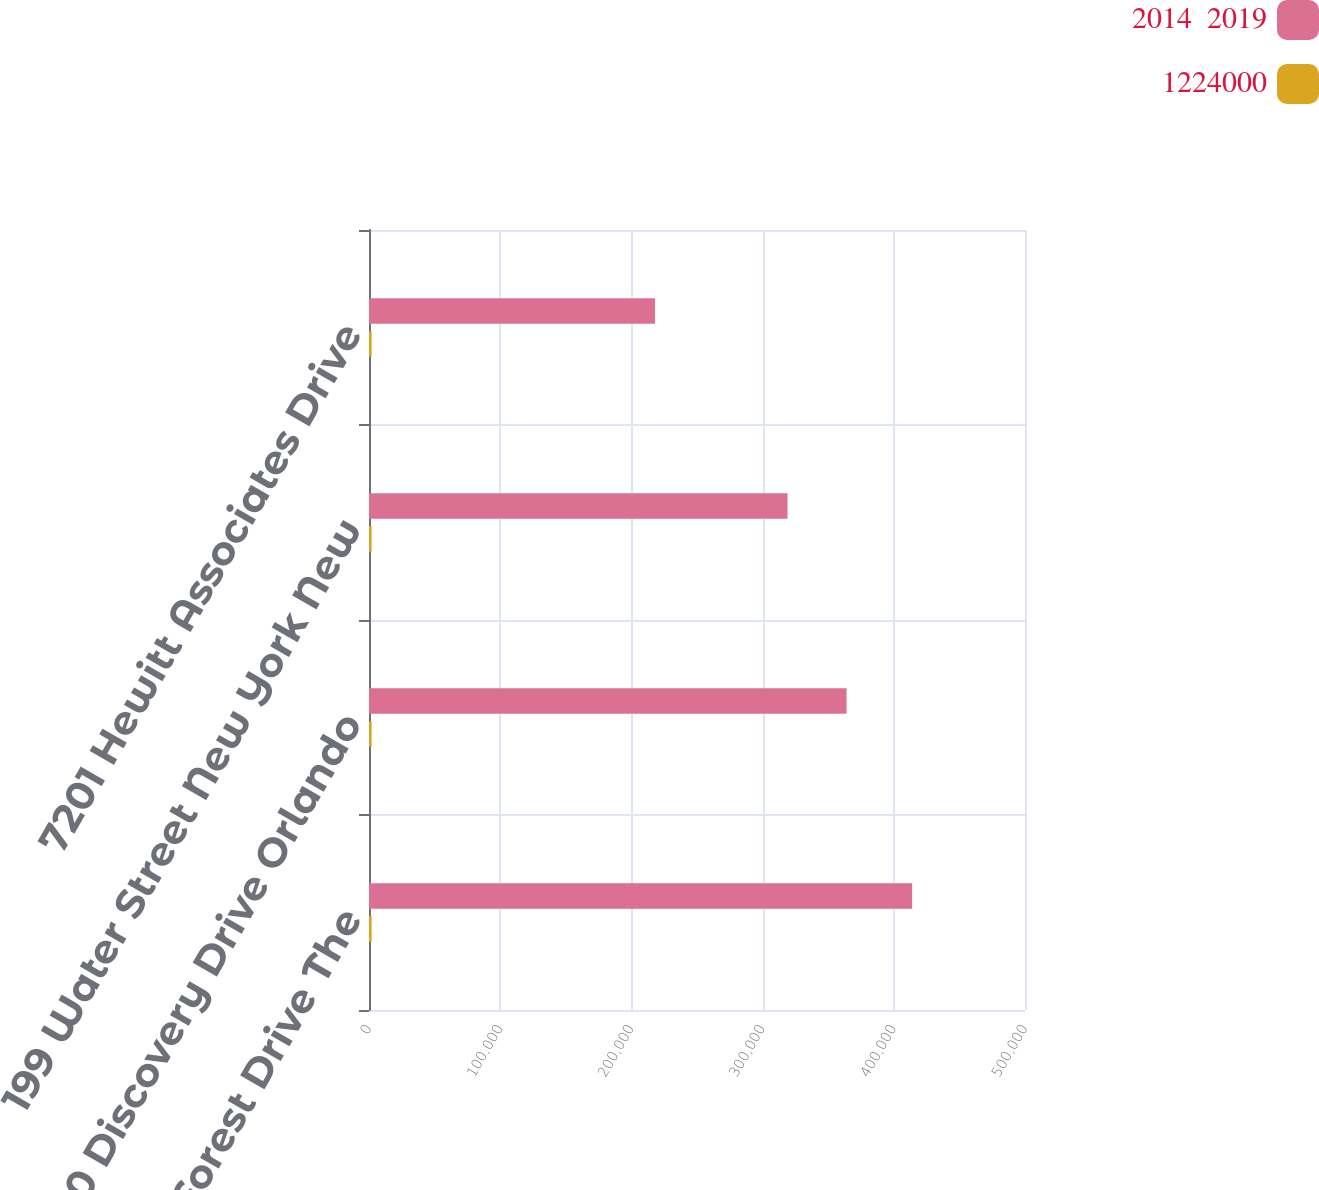<chart> <loc_0><loc_0><loc_500><loc_500><stacked_bar_chart><ecel><fcel>2601 Research Forest Drive The<fcel>2300 Discovery Drive Orlando<fcel>199 Water Street New York New<fcel>7201 Hewitt Associates Drive<nl><fcel>2014  2019<fcel>414000<fcel>364000<fcel>319000<fcel>218000<nl><fcel>1224000<fcel>2020<fcel>2020<fcel>2018<fcel>2015<nl></chart> 